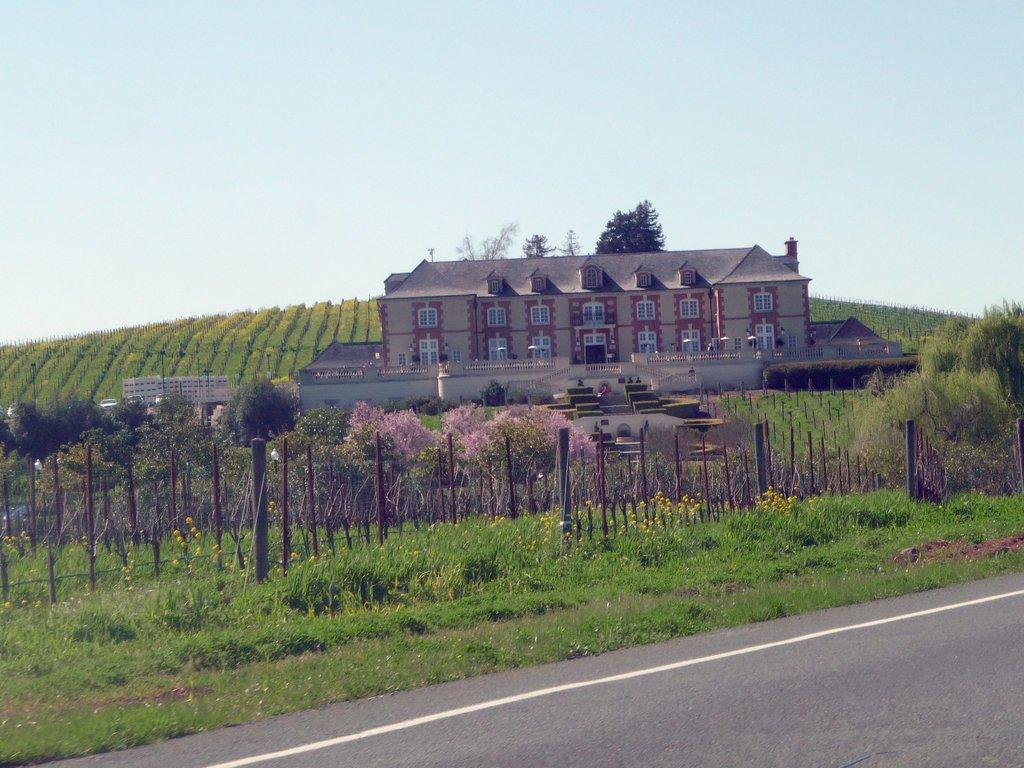What is the main structure visible in the image? There is a building in the image. What type of vegetation surrounds the building? There is a group of trees and plants around the building. What is located in the foreground of the image? There is fencing and grass in the foreground of the image. What type of pathway is visible in the foreground of the image? There is a road in the foreground of the image. What type of sheet is draped over the building in the image? There is no sheet present in the image; the building is not covered by any fabric. 